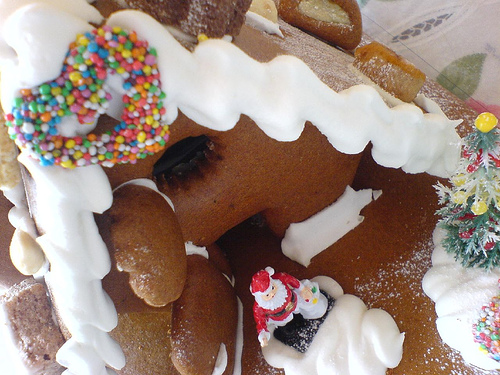<image>
Is there a tree to the right of the santa claus? Yes. From this viewpoint, the tree is positioned to the right side relative to the santa claus. 